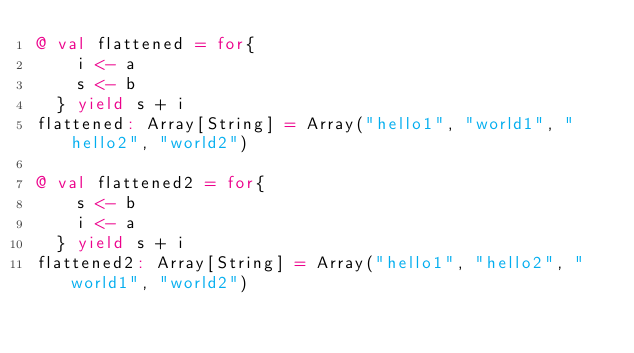<code> <loc_0><loc_0><loc_500><loc_500><_Scala_>@ val flattened = for{
    i <- a
    s <- b
  } yield s + i
flattened: Array[String] = Array("hello1", "world1", "hello2", "world2")

@ val flattened2 = for{
    s <- b
    i <- a
  } yield s + i
flattened2: Array[String] = Array("hello1", "hello2", "world1", "world2")
</code> 